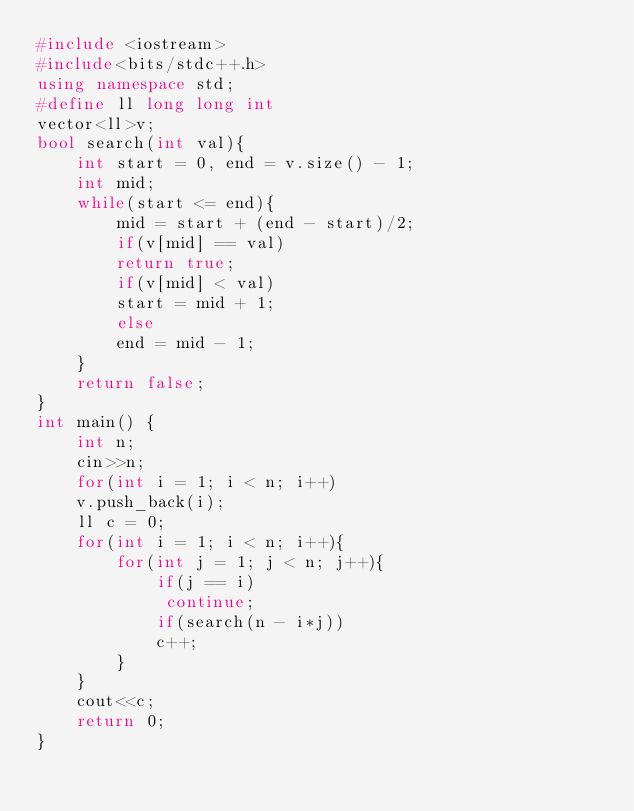Convert code to text. <code><loc_0><loc_0><loc_500><loc_500><_C++_>#include <iostream>
#include<bits/stdc++.h>
using namespace std;
#define ll long long int
vector<ll>v;
bool search(int val){
    int start = 0, end = v.size() - 1;
    int mid;
    while(start <= end){
        mid = start + (end - start)/2;
        if(v[mid] == val)
        return true;
        if(v[mid] < val)
        start = mid + 1;
        else
        end = mid - 1;
    }
    return false;
}
int main() {
	int n;
	cin>>n;
	for(int i = 1; i < n; i++)
	v.push_back(i);
	ll c = 0;
	for(int i = 1; i < n; i++){
	    for(int j = 1; j < n; j++){
	        if(j == i)
	         continue;
	        if(search(n - i*j))
	        c++;
	    }
	}
	cout<<c;
	return 0;
}</code> 